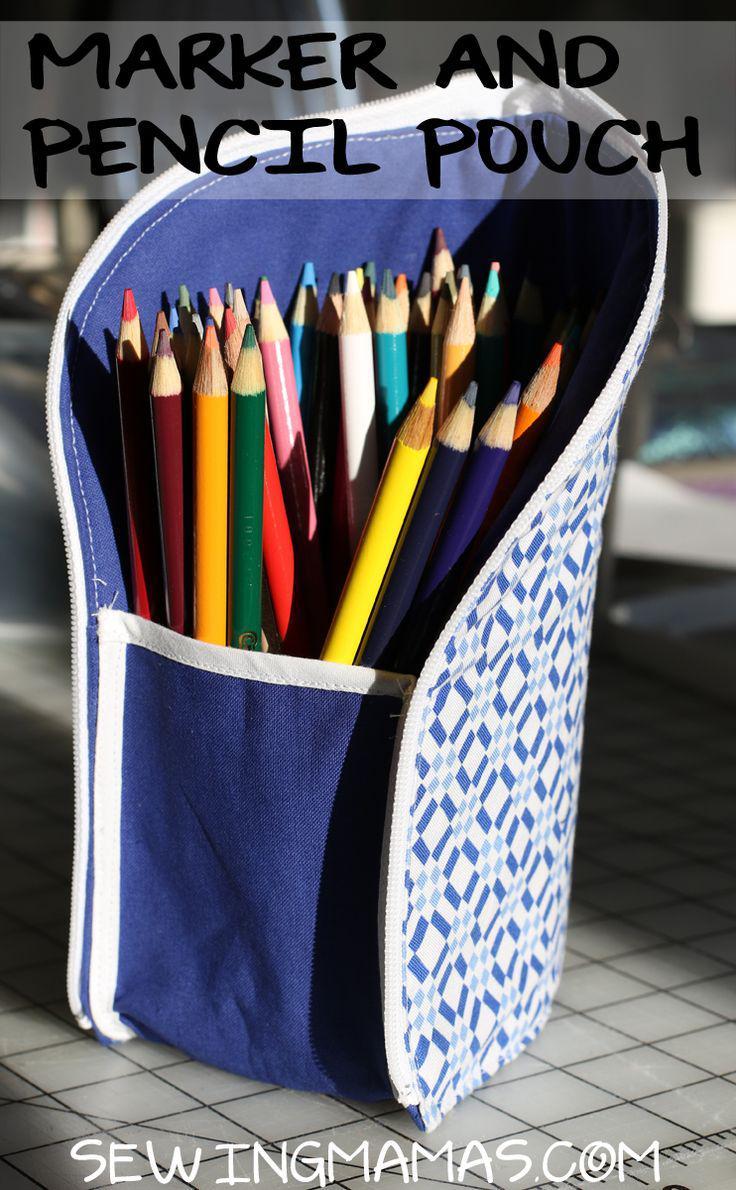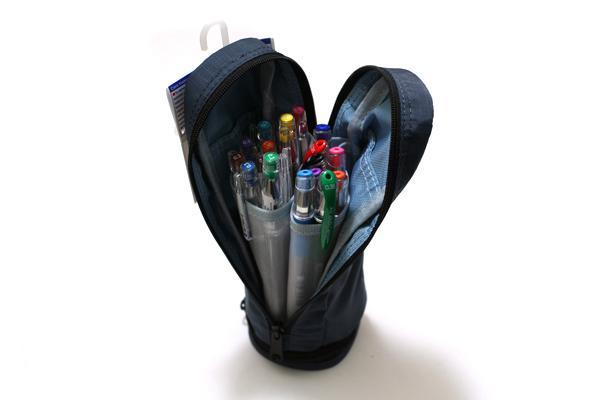The first image is the image on the left, the second image is the image on the right. Evaluate the accuracy of this statement regarding the images: "An image shows an upright pencil pouch with a patterned exterior, filled with only upright colored-lead pencils.". Is it true? Answer yes or no. Yes. The first image is the image on the left, the second image is the image on the right. For the images shown, is this caption "There are two pencil holders in the pair of images." true? Answer yes or no. Yes. 